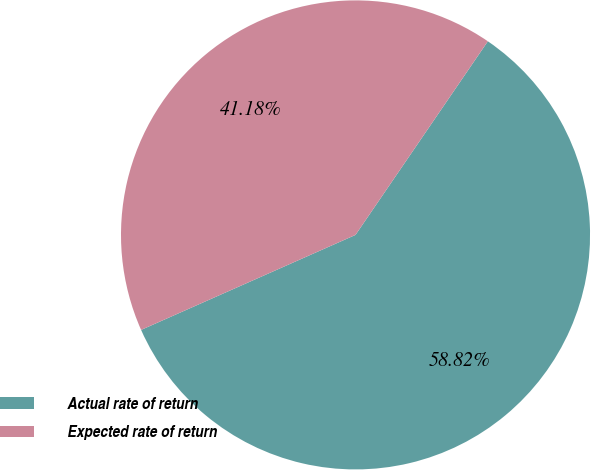Convert chart. <chart><loc_0><loc_0><loc_500><loc_500><pie_chart><fcel>Actual rate of return<fcel>Expected rate of return<nl><fcel>58.82%<fcel>41.18%<nl></chart> 